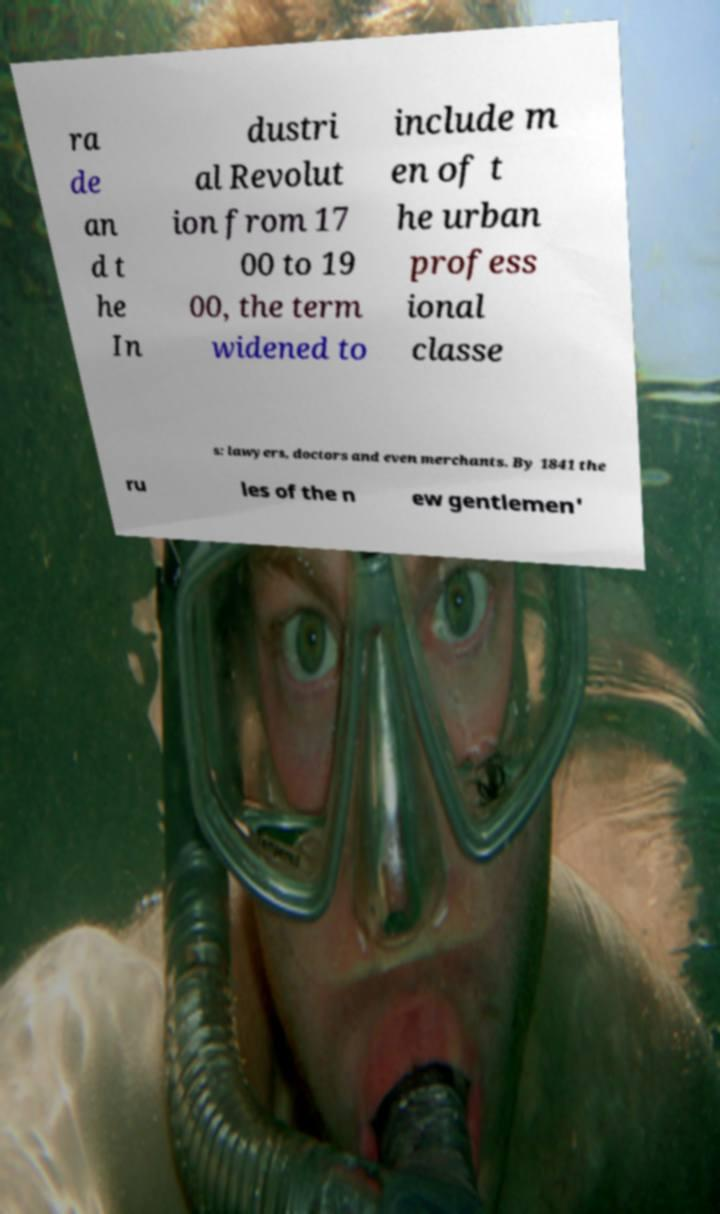Can you accurately transcribe the text from the provided image for me? ra de an d t he In dustri al Revolut ion from 17 00 to 19 00, the term widened to include m en of t he urban profess ional classe s: lawyers, doctors and even merchants. By 1841 the ru les of the n ew gentlemen' 